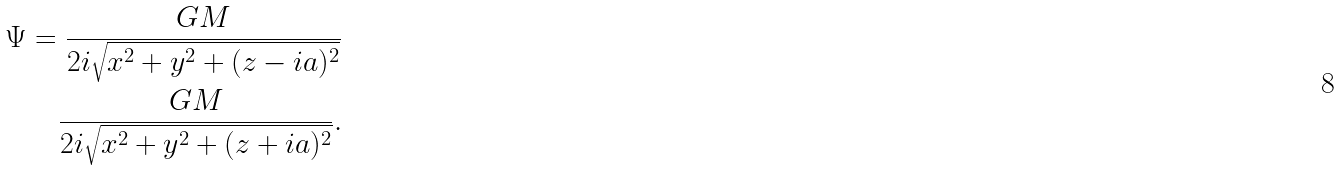<formula> <loc_0><loc_0><loc_500><loc_500>\Psi = \frac { G M } { 2 i \sqrt { x ^ { 2 } + y ^ { 2 } + ( z - i a ) ^ { 2 } } } \\ \frac { G M } { 2 i \sqrt { x ^ { 2 } + y ^ { 2 } + ( z + i a ) ^ { 2 } } } .</formula> 